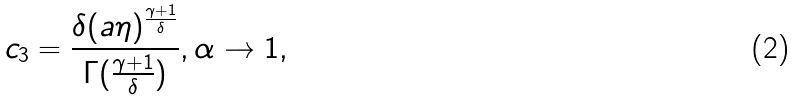<formula> <loc_0><loc_0><loc_500><loc_500>c _ { 3 } = \frac { \delta ( a \eta ) ^ { \frac { \gamma + 1 } { \delta } } } { \Gamma ( \frac { \gamma + 1 } { \delta } ) } , \alpha \rightarrow 1 ,</formula> 